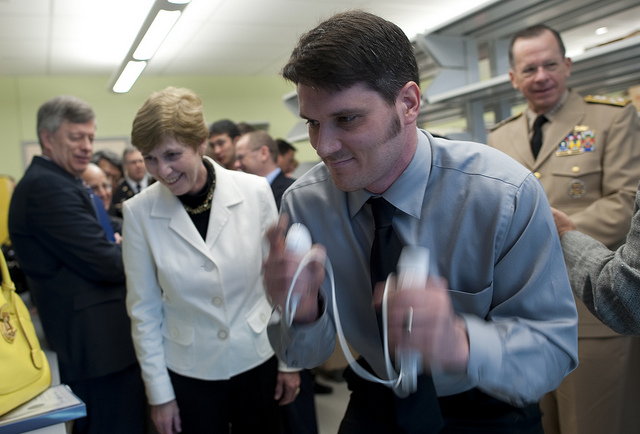How many umbrellas is the man holding? 0 